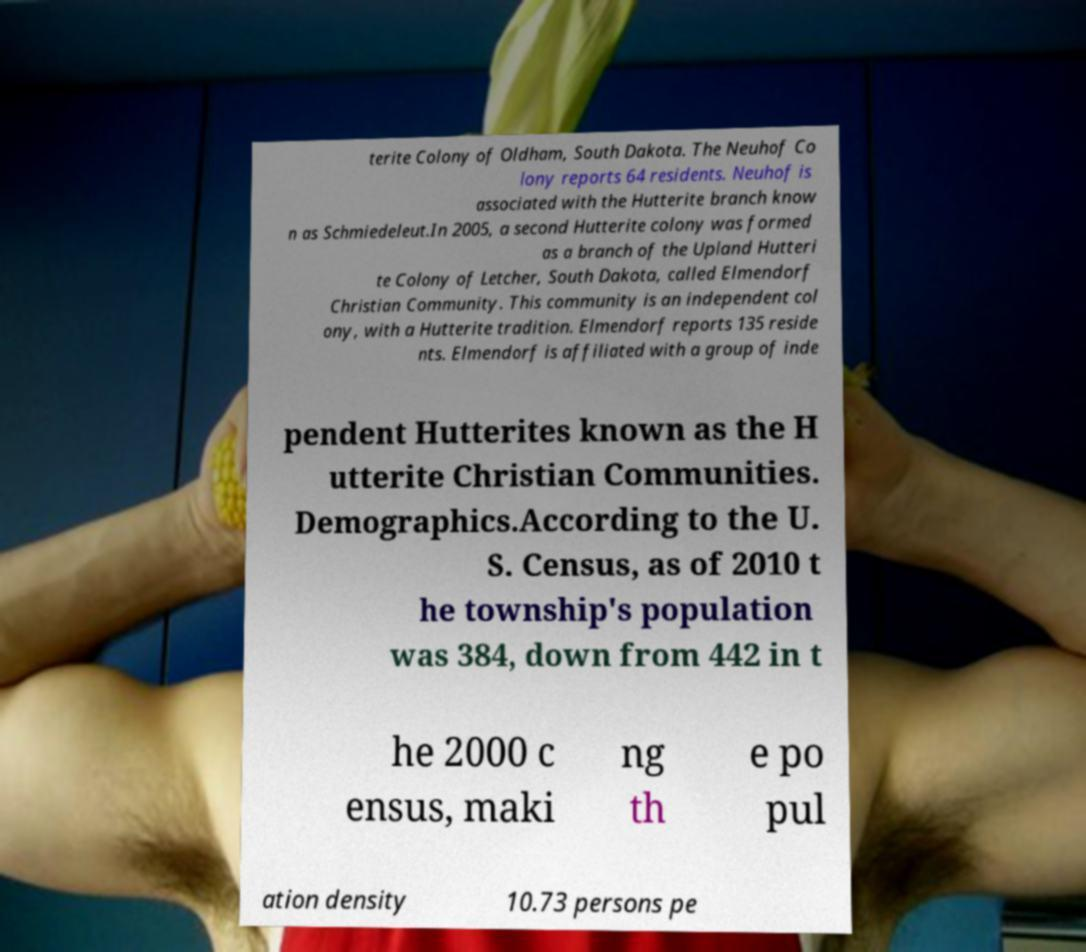Could you assist in decoding the text presented in this image and type it out clearly? terite Colony of Oldham, South Dakota. The Neuhof Co lony reports 64 residents. Neuhof is associated with the Hutterite branch know n as Schmiedeleut.In 2005, a second Hutterite colony was formed as a branch of the Upland Hutteri te Colony of Letcher, South Dakota, called Elmendorf Christian Community. This community is an independent col ony, with a Hutterite tradition. Elmendorf reports 135 reside nts. Elmendorf is affiliated with a group of inde pendent Hutterites known as the H utterite Christian Communities. Demographics.According to the U. S. Census, as of 2010 t he township's population was 384, down from 442 in t he 2000 c ensus, maki ng th e po pul ation density 10.73 persons pe 